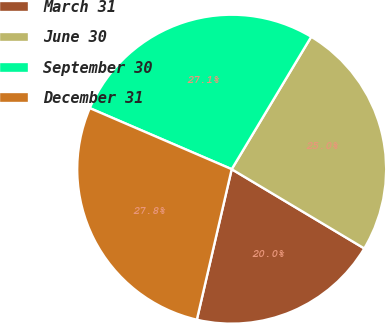Convert chart. <chart><loc_0><loc_0><loc_500><loc_500><pie_chart><fcel>March 31<fcel>June 30<fcel>September 30<fcel>December 31<nl><fcel>20.05%<fcel>24.97%<fcel>27.14%<fcel>27.85%<nl></chart> 